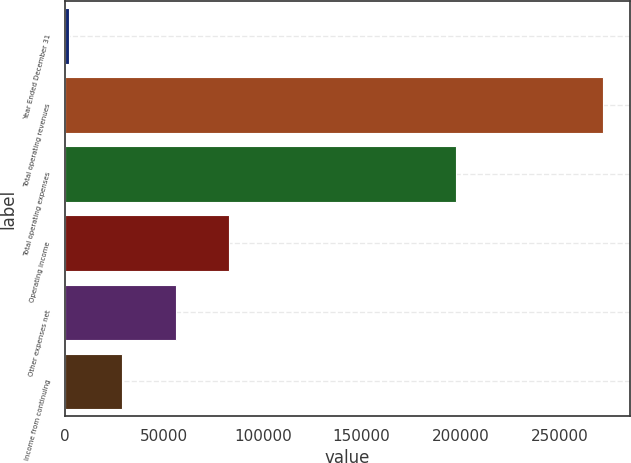Convert chart to OTSL. <chart><loc_0><loc_0><loc_500><loc_500><bar_chart><fcel>Year Ended December 31<fcel>Total operating revenues<fcel>Total operating expenses<fcel>Operating income<fcel>Other expenses net<fcel>Income from continuing<nl><fcel>2006<fcel>272076<fcel>197508<fcel>83027<fcel>56020<fcel>29013<nl></chart> 